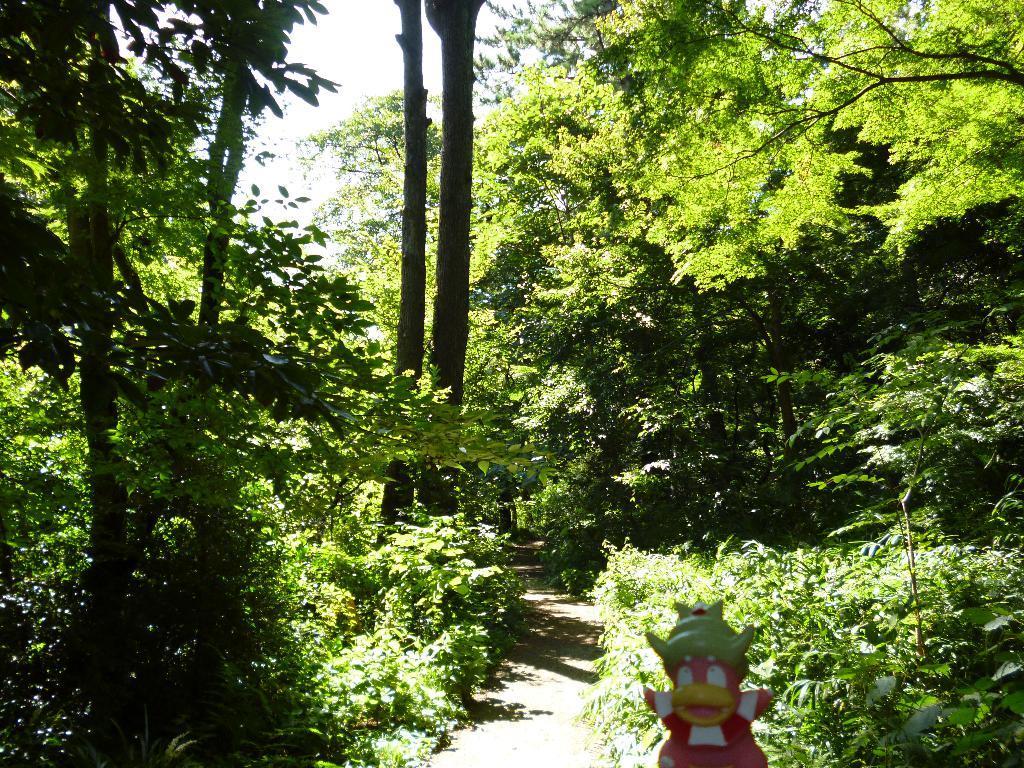Describe this image in one or two sentences. There is a toy, walkway and trees. 